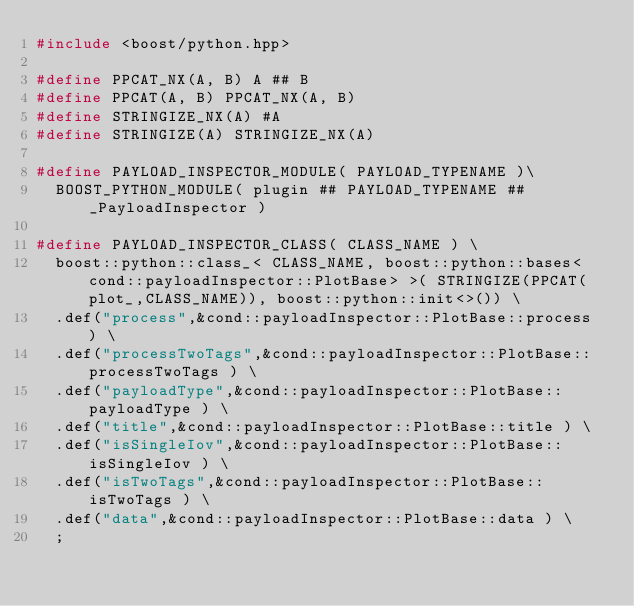<code> <loc_0><loc_0><loc_500><loc_500><_C_>#include <boost/python.hpp>

#define PPCAT_NX(A, B) A ## B
#define PPCAT(A, B) PPCAT_NX(A, B)
#define STRINGIZE_NX(A) #A
#define STRINGIZE(A) STRINGIZE_NX(A)

#define PAYLOAD_INSPECTOR_MODULE( PAYLOAD_TYPENAME )\
  BOOST_PYTHON_MODULE( plugin ## PAYLOAD_TYPENAME ## _PayloadInspector ) 

#define PAYLOAD_INSPECTOR_CLASS( CLASS_NAME ) \
  boost::python::class_< CLASS_NAME, boost::python::bases<cond::payloadInspector::PlotBase> >( STRINGIZE(PPCAT(plot_,CLASS_NAME)), boost::python::init<>()) \
  .def("process",&cond::payloadInspector::PlotBase::process ) \
  .def("processTwoTags",&cond::payloadInspector::PlotBase::processTwoTags ) \
  .def("payloadType",&cond::payloadInspector::PlotBase::payloadType ) \
  .def("title",&cond::payloadInspector::PlotBase::title ) \
  .def("isSingleIov",&cond::payloadInspector::PlotBase::isSingleIov ) \
  .def("isTwoTags",&cond::payloadInspector::PlotBase::isTwoTags ) \
  .def("data",&cond::payloadInspector::PlotBase::data ) \
  ;
</code> 